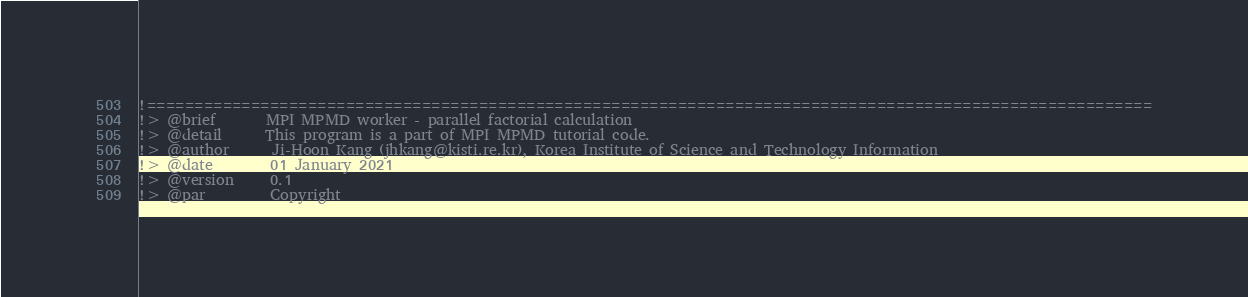<code> <loc_0><loc_0><loc_500><loc_500><_FORTRAN_>
!==========================================================================================================
!> @brief       MPI MPMD worker - parallel factorial calculation
!> @detail      This program is a part of MPI MPMD tutorial code.
!> @author      Ji-Hoon Kang (jhkang@kisti.re.kr), Korea Institute of Science and Technology Information
!> @date        01 January 2021
!> @version     0.1
!> @par         Copyright</code> 